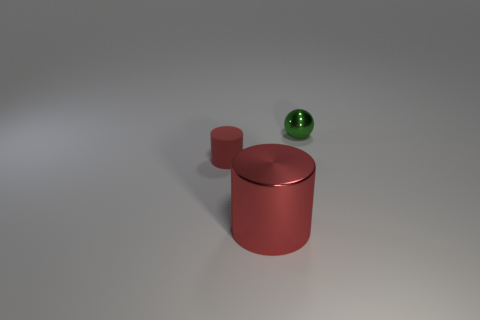There is a metal thing that is in front of the object that is on the right side of the cylinder that is in front of the tiny rubber object; what is its color?
Provide a succinct answer. Red. There is a green thing that is the same size as the red matte object; what is its material?
Provide a succinct answer. Metal. How many large purple blocks are the same material as the green object?
Provide a succinct answer. 0. There is a red cylinder to the left of the big red shiny cylinder; does it have the same size as the red thing that is in front of the red rubber object?
Make the answer very short. No. What is the color of the shiny thing that is in front of the red matte cylinder?
Offer a very short reply. Red. There is another cylinder that is the same color as the big metal cylinder; what material is it?
Give a very brief answer. Rubber. What number of large metal objects are the same color as the small metallic ball?
Your response must be concise. 0. There is a red rubber cylinder; is its size the same as the metal thing that is to the right of the red shiny cylinder?
Give a very brief answer. Yes. What size is the cylinder in front of the small thing in front of the thing that is behind the red rubber cylinder?
Give a very brief answer. Large. There is a green metal ball; how many tiny red rubber things are behind it?
Provide a succinct answer. 0. 